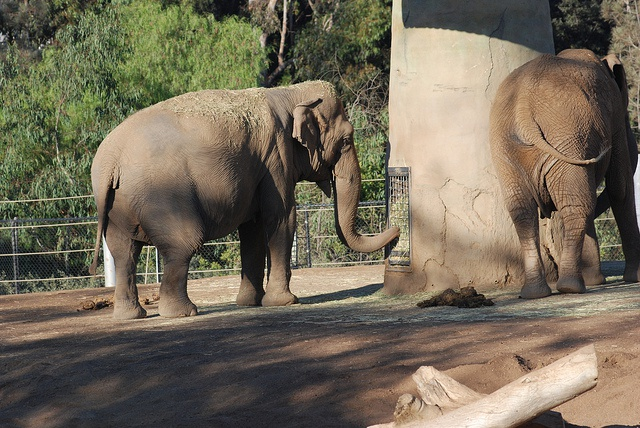Describe the objects in this image and their specific colors. I can see elephant in purple, black, gray, and tan tones and elephant in purple, black, gray, and tan tones in this image. 